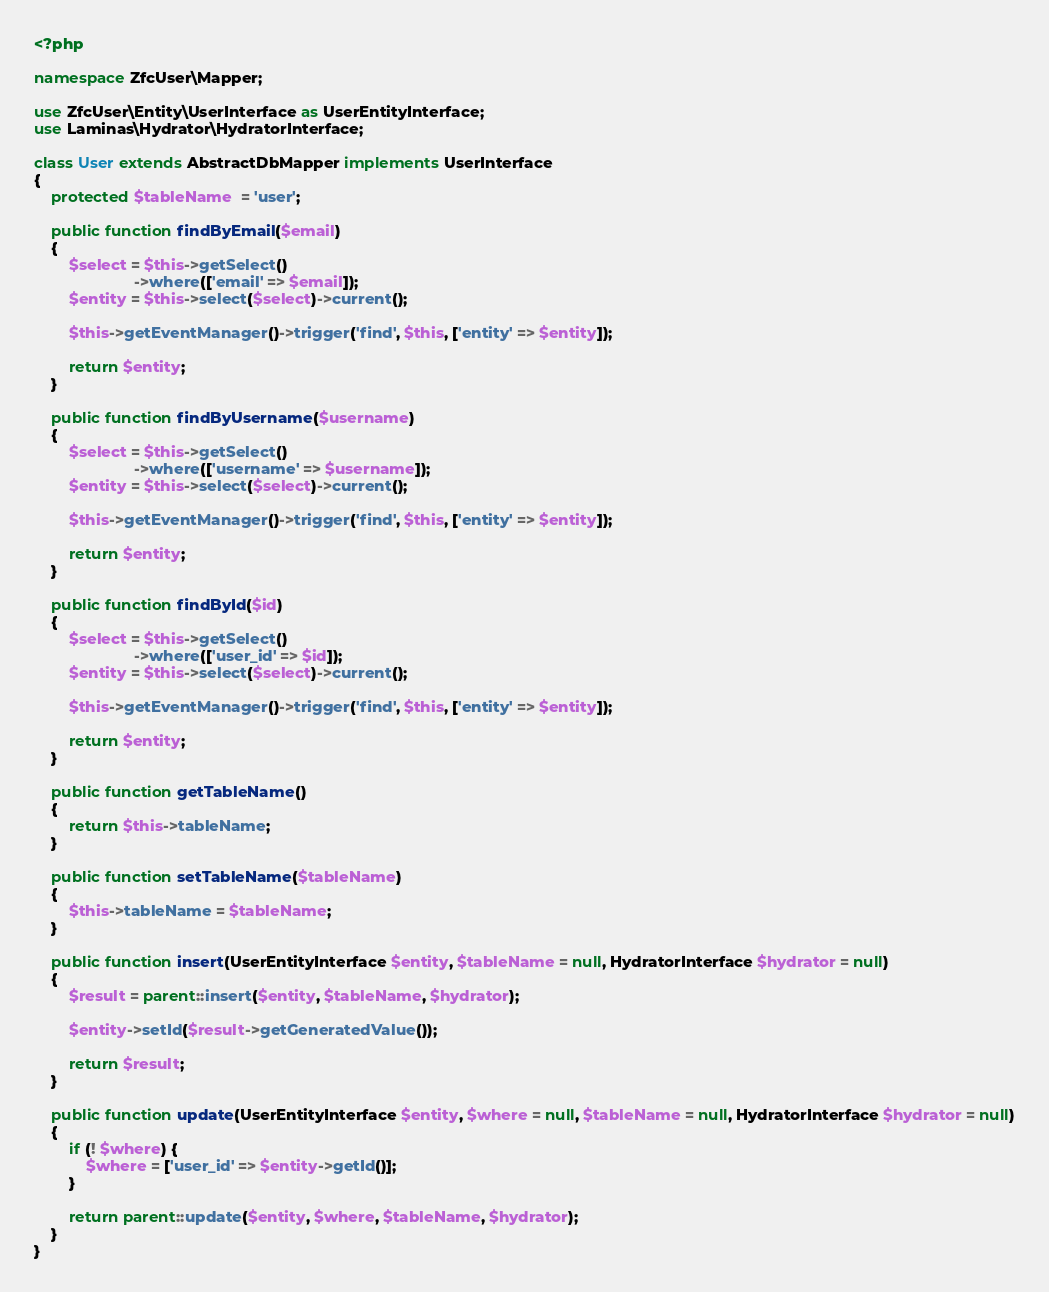<code> <loc_0><loc_0><loc_500><loc_500><_PHP_><?php

namespace ZfcUser\Mapper;

use ZfcUser\Entity\UserInterface as UserEntityInterface;
use Laminas\Hydrator\HydratorInterface;

class User extends AbstractDbMapper implements UserInterface
{
    protected $tableName  = 'user';

    public function findByEmail($email)
    {
        $select = $this->getSelect()
                       ->where(['email' => $email]);
        $entity = $this->select($select)->current();

        $this->getEventManager()->trigger('find', $this, ['entity' => $entity]);

        return $entity;
    }

    public function findByUsername($username)
    {
        $select = $this->getSelect()
                       ->where(['username' => $username]);
        $entity = $this->select($select)->current();

        $this->getEventManager()->trigger('find', $this, ['entity' => $entity]);

        return $entity;
    }

    public function findById($id)
    {
        $select = $this->getSelect()
                       ->where(['user_id' => $id]);
        $entity = $this->select($select)->current();

        $this->getEventManager()->trigger('find', $this, ['entity' => $entity]);

        return $entity;
    }

    public function getTableName()
    {
        return $this->tableName;
    }

    public function setTableName($tableName)
    {
        $this->tableName = $tableName;
    }

    public function insert(UserEntityInterface $entity, $tableName = null, HydratorInterface $hydrator = null)
    {
        $result = parent::insert($entity, $tableName, $hydrator);

        $entity->setId($result->getGeneratedValue());

        return $result;
    }

    public function update(UserEntityInterface $entity, $where = null, $tableName = null, HydratorInterface $hydrator = null)
    {
        if (! $where) {
            $where = ['user_id' => $entity->getId()];
        }

        return parent::update($entity, $where, $tableName, $hydrator);
    }
}
</code> 